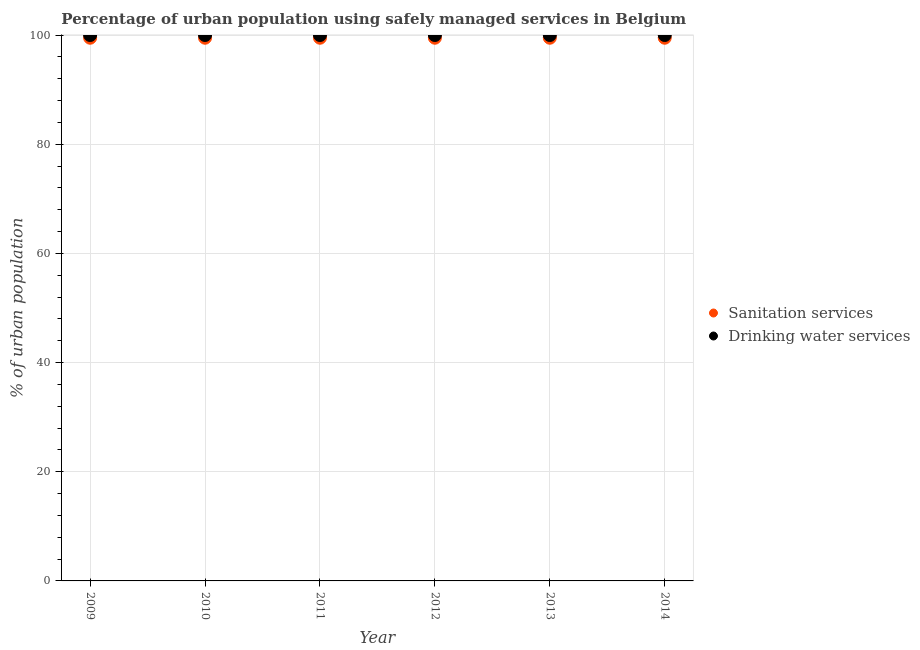How many different coloured dotlines are there?
Offer a terse response. 2. What is the percentage of urban population who used sanitation services in 2012?
Your answer should be very brief. 99.5. Across all years, what is the maximum percentage of urban population who used drinking water services?
Your answer should be compact. 100. Across all years, what is the minimum percentage of urban population who used sanitation services?
Provide a short and direct response. 99.5. In which year was the percentage of urban population who used sanitation services maximum?
Your answer should be compact. 2009. In which year was the percentage of urban population who used sanitation services minimum?
Your response must be concise. 2009. What is the total percentage of urban population who used drinking water services in the graph?
Your answer should be very brief. 600. What is the difference between the percentage of urban population who used sanitation services in 2011 and the percentage of urban population who used drinking water services in 2009?
Give a very brief answer. -0.5. What is the average percentage of urban population who used sanitation services per year?
Provide a succinct answer. 99.5. In the year 2014, what is the difference between the percentage of urban population who used drinking water services and percentage of urban population who used sanitation services?
Your response must be concise. 0.5. Is the percentage of urban population who used drinking water services in 2009 less than that in 2011?
Your answer should be compact. No. Is the difference between the percentage of urban population who used sanitation services in 2009 and 2010 greater than the difference between the percentage of urban population who used drinking water services in 2009 and 2010?
Make the answer very short. No. What is the difference between the highest and the lowest percentage of urban population who used sanitation services?
Ensure brevity in your answer.  0. In how many years, is the percentage of urban population who used drinking water services greater than the average percentage of urban population who used drinking water services taken over all years?
Provide a succinct answer. 0. Is the percentage of urban population who used sanitation services strictly greater than the percentage of urban population who used drinking water services over the years?
Keep it short and to the point. No. How many dotlines are there?
Your answer should be very brief. 2. Does the graph contain grids?
Your answer should be very brief. Yes. Where does the legend appear in the graph?
Your response must be concise. Center right. How many legend labels are there?
Give a very brief answer. 2. How are the legend labels stacked?
Keep it short and to the point. Vertical. What is the title of the graph?
Keep it short and to the point. Percentage of urban population using safely managed services in Belgium. What is the label or title of the X-axis?
Make the answer very short. Year. What is the label or title of the Y-axis?
Make the answer very short. % of urban population. What is the % of urban population of Sanitation services in 2009?
Your answer should be compact. 99.5. What is the % of urban population in Drinking water services in 2009?
Provide a short and direct response. 100. What is the % of urban population in Sanitation services in 2010?
Your answer should be very brief. 99.5. What is the % of urban population of Sanitation services in 2011?
Provide a succinct answer. 99.5. What is the % of urban population of Drinking water services in 2011?
Provide a succinct answer. 100. What is the % of urban population of Sanitation services in 2012?
Offer a very short reply. 99.5. What is the % of urban population in Drinking water services in 2012?
Give a very brief answer. 100. What is the % of urban population of Sanitation services in 2013?
Your answer should be compact. 99.5. What is the % of urban population of Sanitation services in 2014?
Provide a short and direct response. 99.5. Across all years, what is the maximum % of urban population of Sanitation services?
Your answer should be very brief. 99.5. Across all years, what is the maximum % of urban population of Drinking water services?
Give a very brief answer. 100. Across all years, what is the minimum % of urban population of Sanitation services?
Your answer should be very brief. 99.5. Across all years, what is the minimum % of urban population in Drinking water services?
Make the answer very short. 100. What is the total % of urban population of Sanitation services in the graph?
Your response must be concise. 597. What is the total % of urban population of Drinking water services in the graph?
Your answer should be compact. 600. What is the difference between the % of urban population of Sanitation services in 2009 and that in 2010?
Give a very brief answer. 0. What is the difference between the % of urban population of Drinking water services in 2009 and that in 2010?
Your response must be concise. 0. What is the difference between the % of urban population of Sanitation services in 2009 and that in 2011?
Keep it short and to the point. 0. What is the difference between the % of urban population in Sanitation services in 2009 and that in 2012?
Your answer should be very brief. 0. What is the difference between the % of urban population of Drinking water services in 2009 and that in 2012?
Provide a succinct answer. 0. What is the difference between the % of urban population in Sanitation services in 2009 and that in 2013?
Provide a succinct answer. 0. What is the difference between the % of urban population of Drinking water services in 2009 and that in 2013?
Your answer should be very brief. 0. What is the difference between the % of urban population in Drinking water services in 2009 and that in 2014?
Your response must be concise. 0. What is the difference between the % of urban population in Drinking water services in 2010 and that in 2011?
Provide a short and direct response. 0. What is the difference between the % of urban population in Drinking water services in 2010 and that in 2012?
Offer a terse response. 0. What is the difference between the % of urban population of Sanitation services in 2010 and that in 2013?
Your response must be concise. 0. What is the difference between the % of urban population in Sanitation services in 2010 and that in 2014?
Provide a short and direct response. 0. What is the difference between the % of urban population of Drinking water services in 2010 and that in 2014?
Provide a short and direct response. 0. What is the difference between the % of urban population in Sanitation services in 2011 and that in 2012?
Your response must be concise. 0. What is the difference between the % of urban population of Drinking water services in 2011 and that in 2012?
Your answer should be compact. 0. What is the difference between the % of urban population in Drinking water services in 2011 and that in 2013?
Offer a terse response. 0. What is the difference between the % of urban population of Sanitation services in 2011 and that in 2014?
Give a very brief answer. 0. What is the difference between the % of urban population in Sanitation services in 2012 and that in 2013?
Make the answer very short. 0. What is the difference between the % of urban population in Drinking water services in 2012 and that in 2013?
Give a very brief answer. 0. What is the difference between the % of urban population of Sanitation services in 2012 and that in 2014?
Ensure brevity in your answer.  0. What is the difference between the % of urban population of Drinking water services in 2012 and that in 2014?
Give a very brief answer. 0. What is the difference between the % of urban population in Sanitation services in 2009 and the % of urban population in Drinking water services in 2010?
Offer a terse response. -0.5. What is the difference between the % of urban population of Sanitation services in 2009 and the % of urban population of Drinking water services in 2012?
Provide a succinct answer. -0.5. What is the difference between the % of urban population in Sanitation services in 2009 and the % of urban population in Drinking water services in 2013?
Provide a succinct answer. -0.5. What is the difference between the % of urban population in Sanitation services in 2009 and the % of urban population in Drinking water services in 2014?
Your answer should be compact. -0.5. What is the difference between the % of urban population of Sanitation services in 2010 and the % of urban population of Drinking water services in 2013?
Ensure brevity in your answer.  -0.5. What is the difference between the % of urban population of Sanitation services in 2010 and the % of urban population of Drinking water services in 2014?
Offer a very short reply. -0.5. What is the difference between the % of urban population of Sanitation services in 2011 and the % of urban population of Drinking water services in 2013?
Your response must be concise. -0.5. What is the difference between the % of urban population of Sanitation services in 2012 and the % of urban population of Drinking water services in 2013?
Offer a very short reply. -0.5. What is the difference between the % of urban population of Sanitation services in 2013 and the % of urban population of Drinking water services in 2014?
Keep it short and to the point. -0.5. What is the average % of urban population in Sanitation services per year?
Your response must be concise. 99.5. In the year 2009, what is the difference between the % of urban population in Sanitation services and % of urban population in Drinking water services?
Ensure brevity in your answer.  -0.5. In the year 2010, what is the difference between the % of urban population in Sanitation services and % of urban population in Drinking water services?
Your answer should be very brief. -0.5. In the year 2013, what is the difference between the % of urban population of Sanitation services and % of urban population of Drinking water services?
Offer a terse response. -0.5. In the year 2014, what is the difference between the % of urban population of Sanitation services and % of urban population of Drinking water services?
Keep it short and to the point. -0.5. What is the ratio of the % of urban population of Sanitation services in 2009 to that in 2010?
Give a very brief answer. 1. What is the ratio of the % of urban population in Sanitation services in 2009 to that in 2011?
Keep it short and to the point. 1. What is the ratio of the % of urban population in Drinking water services in 2009 to that in 2011?
Offer a terse response. 1. What is the ratio of the % of urban population in Sanitation services in 2009 to that in 2012?
Provide a short and direct response. 1. What is the ratio of the % of urban population of Drinking water services in 2009 to that in 2013?
Your answer should be very brief. 1. What is the ratio of the % of urban population of Sanitation services in 2009 to that in 2014?
Give a very brief answer. 1. What is the ratio of the % of urban population in Drinking water services in 2009 to that in 2014?
Offer a very short reply. 1. What is the ratio of the % of urban population of Sanitation services in 2010 to that in 2011?
Provide a succinct answer. 1. What is the ratio of the % of urban population in Drinking water services in 2010 to that in 2012?
Ensure brevity in your answer.  1. What is the ratio of the % of urban population in Sanitation services in 2010 to that in 2013?
Give a very brief answer. 1. What is the ratio of the % of urban population of Drinking water services in 2010 to that in 2013?
Make the answer very short. 1. What is the ratio of the % of urban population in Drinking water services in 2010 to that in 2014?
Keep it short and to the point. 1. What is the ratio of the % of urban population in Sanitation services in 2011 to that in 2012?
Ensure brevity in your answer.  1. What is the ratio of the % of urban population of Sanitation services in 2011 to that in 2013?
Provide a succinct answer. 1. What is the ratio of the % of urban population of Drinking water services in 2011 to that in 2013?
Your response must be concise. 1. What is the ratio of the % of urban population of Sanitation services in 2011 to that in 2014?
Give a very brief answer. 1. What is the ratio of the % of urban population in Drinking water services in 2011 to that in 2014?
Ensure brevity in your answer.  1. What is the ratio of the % of urban population in Sanitation services in 2012 to that in 2013?
Keep it short and to the point. 1. What is the ratio of the % of urban population in Drinking water services in 2012 to that in 2013?
Offer a very short reply. 1. What is the ratio of the % of urban population of Sanitation services in 2012 to that in 2014?
Your answer should be compact. 1. What is the ratio of the % of urban population of Sanitation services in 2013 to that in 2014?
Your answer should be compact. 1. What is the difference between the highest and the second highest % of urban population of Drinking water services?
Offer a very short reply. 0. 